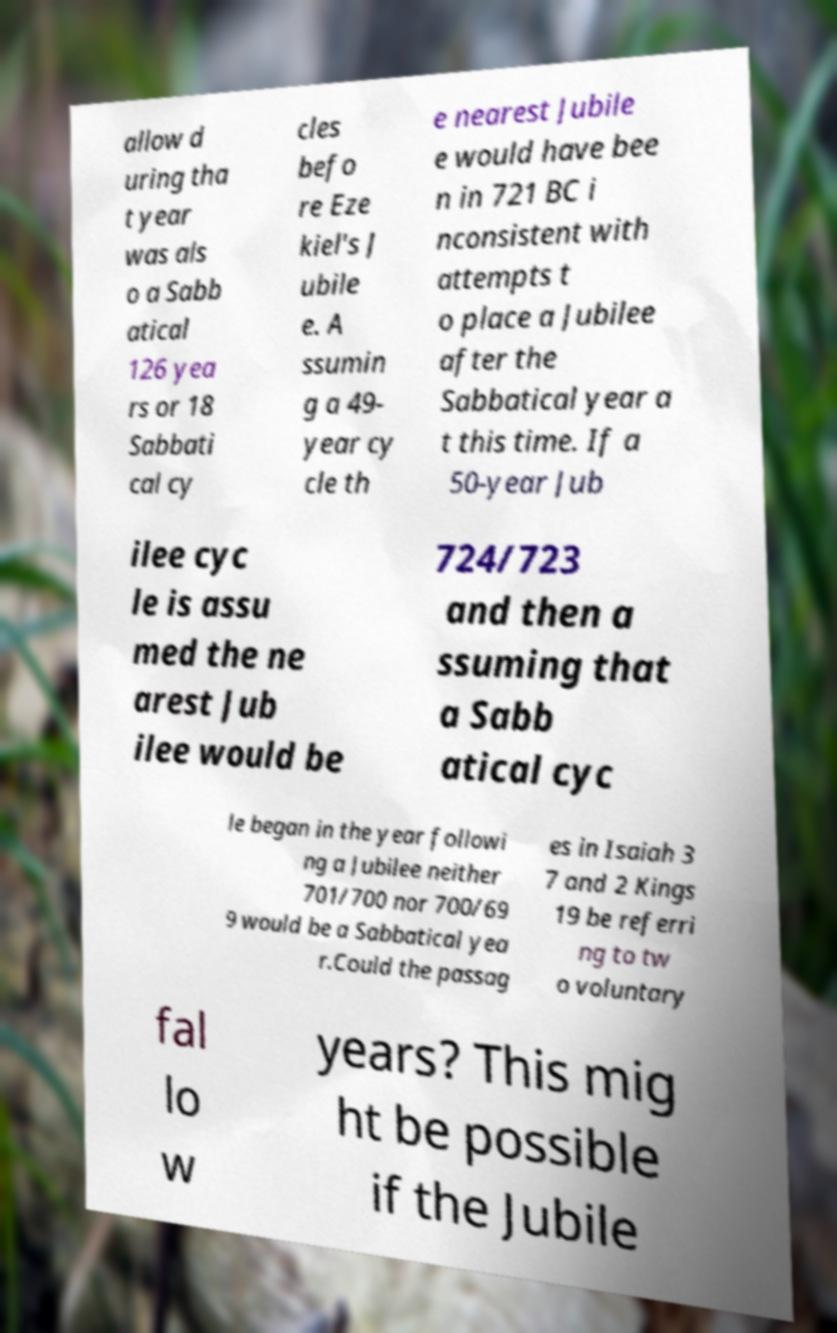What messages or text are displayed in this image? I need them in a readable, typed format. allow d uring tha t year was als o a Sabb atical 126 yea rs or 18 Sabbati cal cy cles befo re Eze kiel's J ubile e. A ssumin g a 49- year cy cle th e nearest Jubile e would have bee n in 721 BC i nconsistent with attempts t o place a Jubilee after the Sabbatical year a t this time. If a 50-year Jub ilee cyc le is assu med the ne arest Jub ilee would be 724/723 and then a ssuming that a Sabb atical cyc le began in the year followi ng a Jubilee neither 701/700 nor 700/69 9 would be a Sabbatical yea r.Could the passag es in Isaiah 3 7 and 2 Kings 19 be referri ng to tw o voluntary fal lo w years? This mig ht be possible if the Jubile 